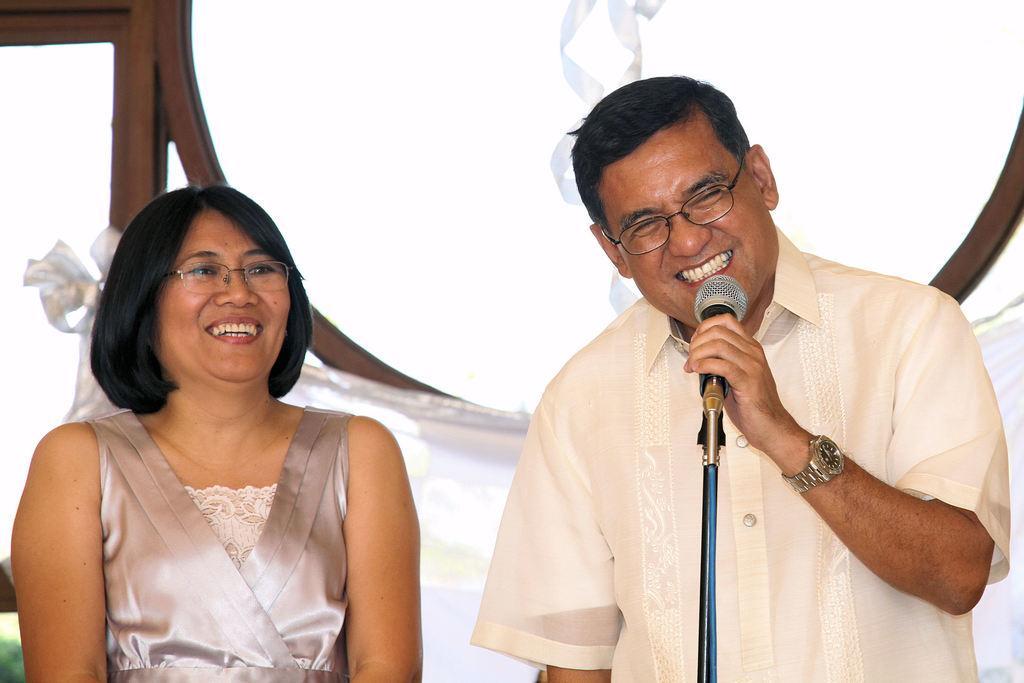Could you give a brief overview of what you see in this image? Here, at the right side we can see a man standing and he is holding a microphone, he is wearing specs, at the left side there is a woman standing and she is smiling, she is wearing specs. 